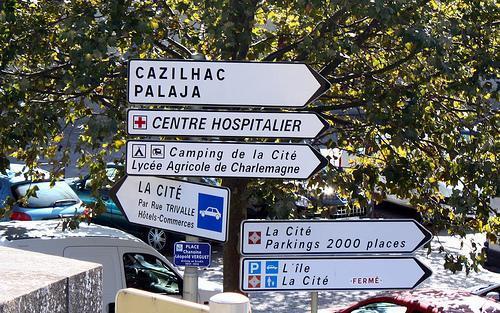How many signs are in this picture?
Give a very brief answer. 7. 